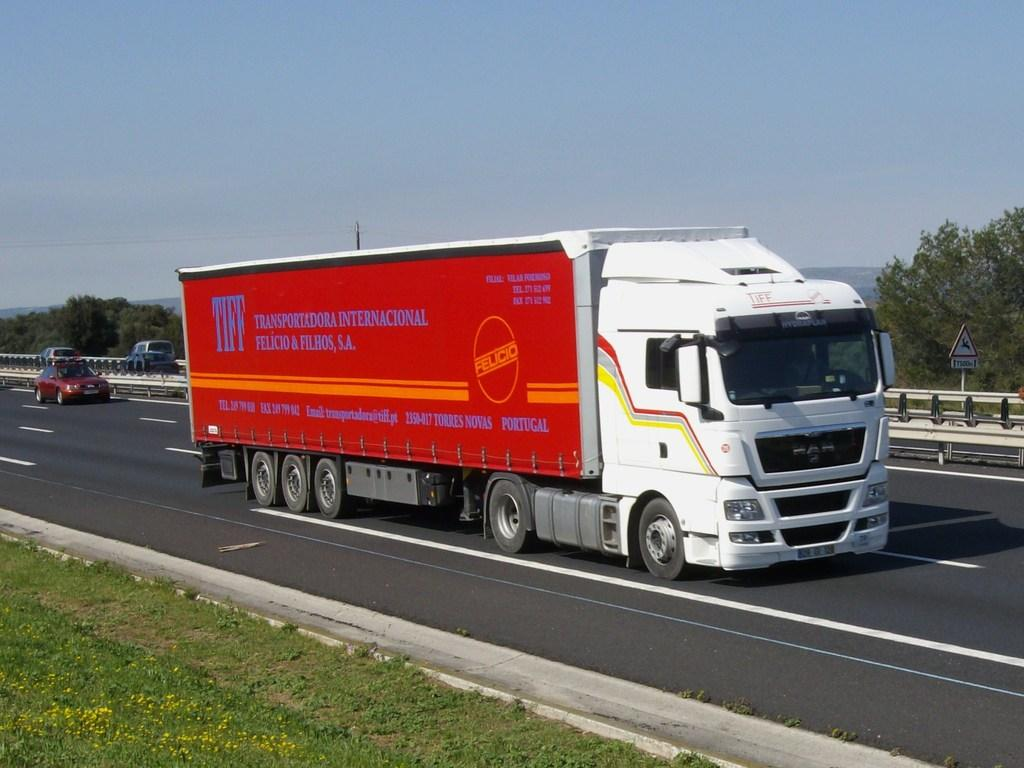What type of vehicle is in the image? There is a truck in the image. What colors can be seen on the truck? The truck is white and red in color. What is happening on the road in the image? There are vehicles moving on the road in the image. What type of vegetation is visible on the ground? There is grass visible on the ground. What other natural elements can be seen in the image? There are trees in the image. How would you describe the weather based on the image? The sky is cloudy in the image, suggesting overcast or potentially rainy weather. What type of appliance is being advertised on the truck in the image? There is no appliance being advertised on the truck in the image; it is simply a white and red truck with no visible advertisements. How many clams are visible on the grass in the image? There are no clams present in the image; the grass is not associated with any seafood. 